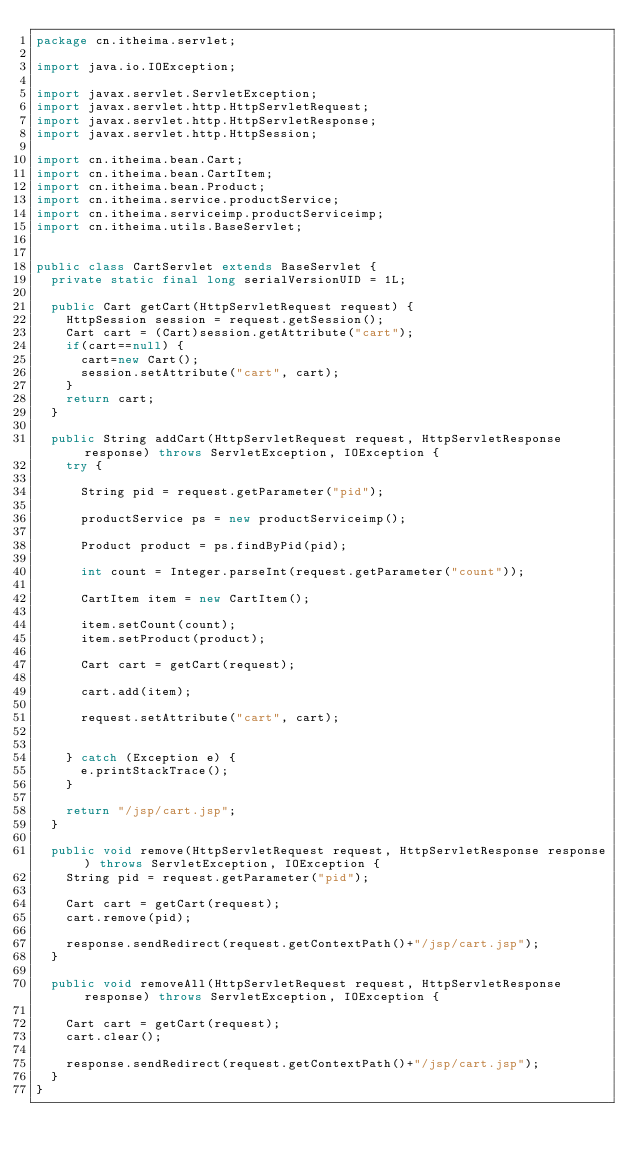<code> <loc_0><loc_0><loc_500><loc_500><_Java_>package cn.itheima.servlet;

import java.io.IOException;

import javax.servlet.ServletException;
import javax.servlet.http.HttpServletRequest;
import javax.servlet.http.HttpServletResponse;
import javax.servlet.http.HttpSession;

import cn.itheima.bean.Cart;
import cn.itheima.bean.CartItem;
import cn.itheima.bean.Product;
import cn.itheima.service.productService;
import cn.itheima.serviceimp.productServiceimp;
import cn.itheima.utils.BaseServlet;


public class CartServlet extends BaseServlet {
	private static final long serialVersionUID = 1L;
	
	public Cart getCart(HttpServletRequest request) {
		HttpSession session = request.getSession();
		Cart cart = (Cart)session.getAttribute("cart");
		if(cart==null) {
			cart=new Cart();
			session.setAttribute("cart", cart);
		}
		return cart;
	}
	
	public String addCart(HttpServletRequest request, HttpServletResponse response) throws ServletException, IOException {
		try {
			
			String pid = request.getParameter("pid");
			
			productService ps = new productServiceimp();
			
			Product product = ps.findByPid(pid);
		
			int count = Integer.parseInt(request.getParameter("count"));
			
			CartItem item = new CartItem();
			
			item.setCount(count);
			item.setProduct(product);
			
			Cart cart = getCart(request);
			
			cart.add(item);
			
			request.setAttribute("cart", cart);
			
			
		} catch (Exception e) {
			e.printStackTrace();
		}
		
		return "/jsp/cart.jsp";
	}
	
	public void remove(HttpServletRequest request, HttpServletResponse response) throws ServletException, IOException {
		String pid = request.getParameter("pid");
		
		Cart cart = getCart(request);
		cart.remove(pid);
		
		response.sendRedirect(request.getContextPath()+"/jsp/cart.jsp");
	}
	
	public void removeAll(HttpServletRequest request, HttpServletResponse response) throws ServletException, IOException {
	
		Cart cart = getCart(request);
		cart.clear();
		
		response.sendRedirect(request.getContextPath()+"/jsp/cart.jsp");
	}
}
</code> 